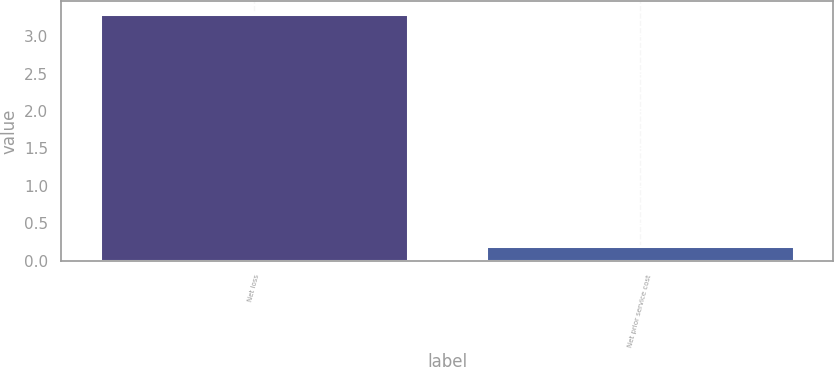Convert chart to OTSL. <chart><loc_0><loc_0><loc_500><loc_500><bar_chart><fcel>Net loss<fcel>Net prior service cost<nl><fcel>3.3<fcel>0.2<nl></chart> 